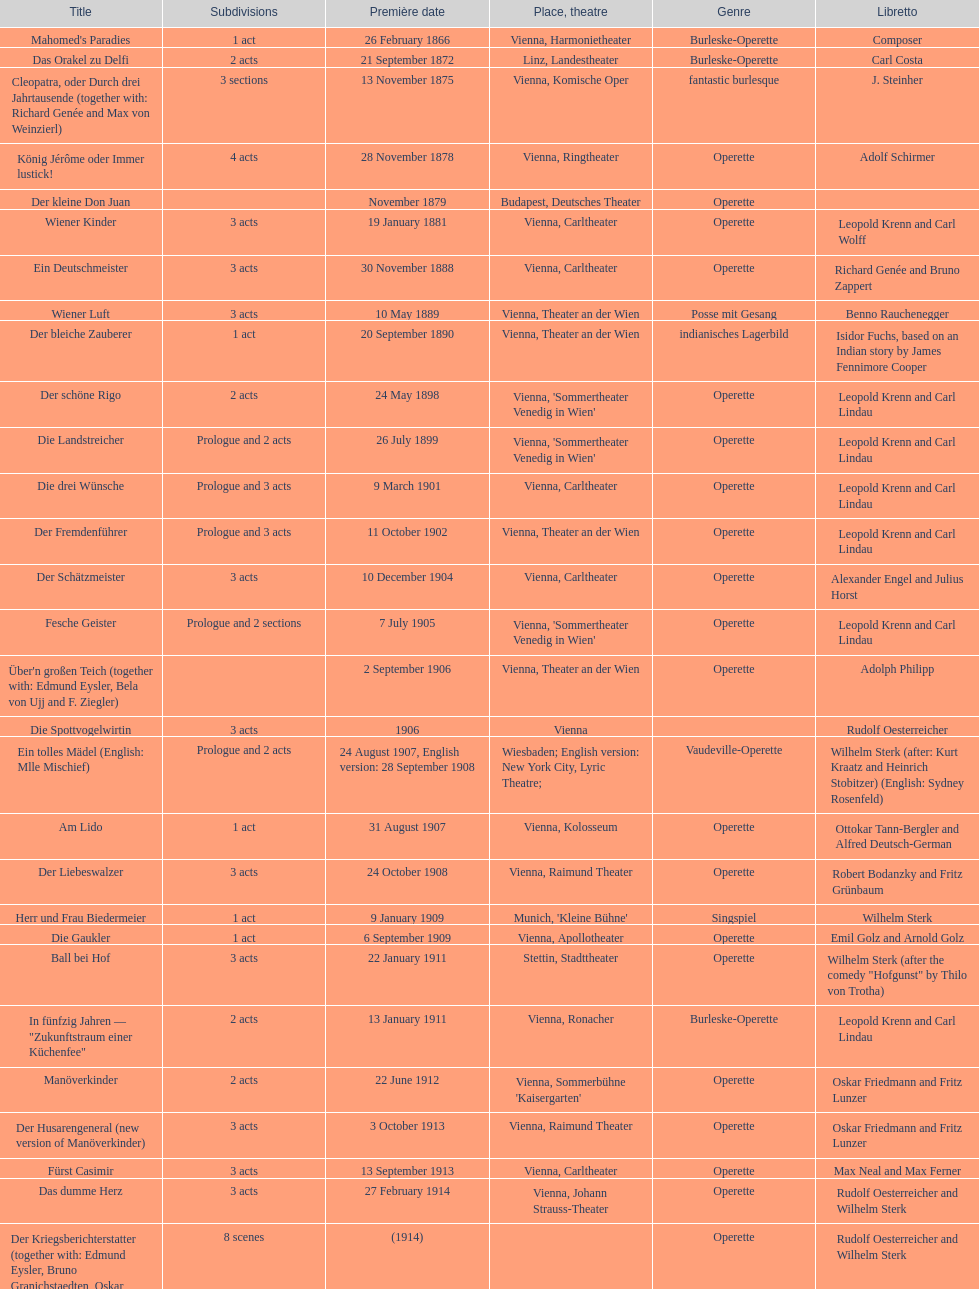In which town did the most operettas debut? Vienna. 